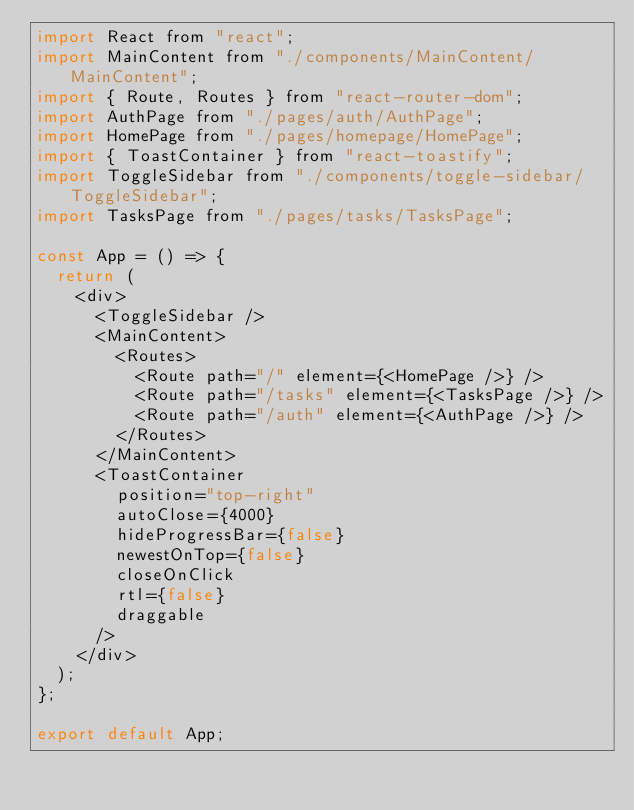<code> <loc_0><loc_0><loc_500><loc_500><_JavaScript_>import React from "react";
import MainContent from "./components/MainContent/MainContent";
import { Route, Routes } from "react-router-dom";
import AuthPage from "./pages/auth/AuthPage";
import HomePage from "./pages/homepage/HomePage";
import { ToastContainer } from "react-toastify";
import ToggleSidebar from "./components/toggle-sidebar/ToggleSidebar";
import TasksPage from "./pages/tasks/TasksPage";

const App = () => {
  return (
    <div>
      <ToggleSidebar />
      <MainContent>
        <Routes>
          <Route path="/" element={<HomePage />} />
          <Route path="/tasks" element={<TasksPage />} />
          <Route path="/auth" element={<AuthPage />} />
        </Routes>
      </MainContent>
      <ToastContainer
        position="top-right"
        autoClose={4000}
        hideProgressBar={false}
        newestOnTop={false}
        closeOnClick
        rtl={false}
        draggable
      />
    </div>
  );
};

export default App;
</code> 